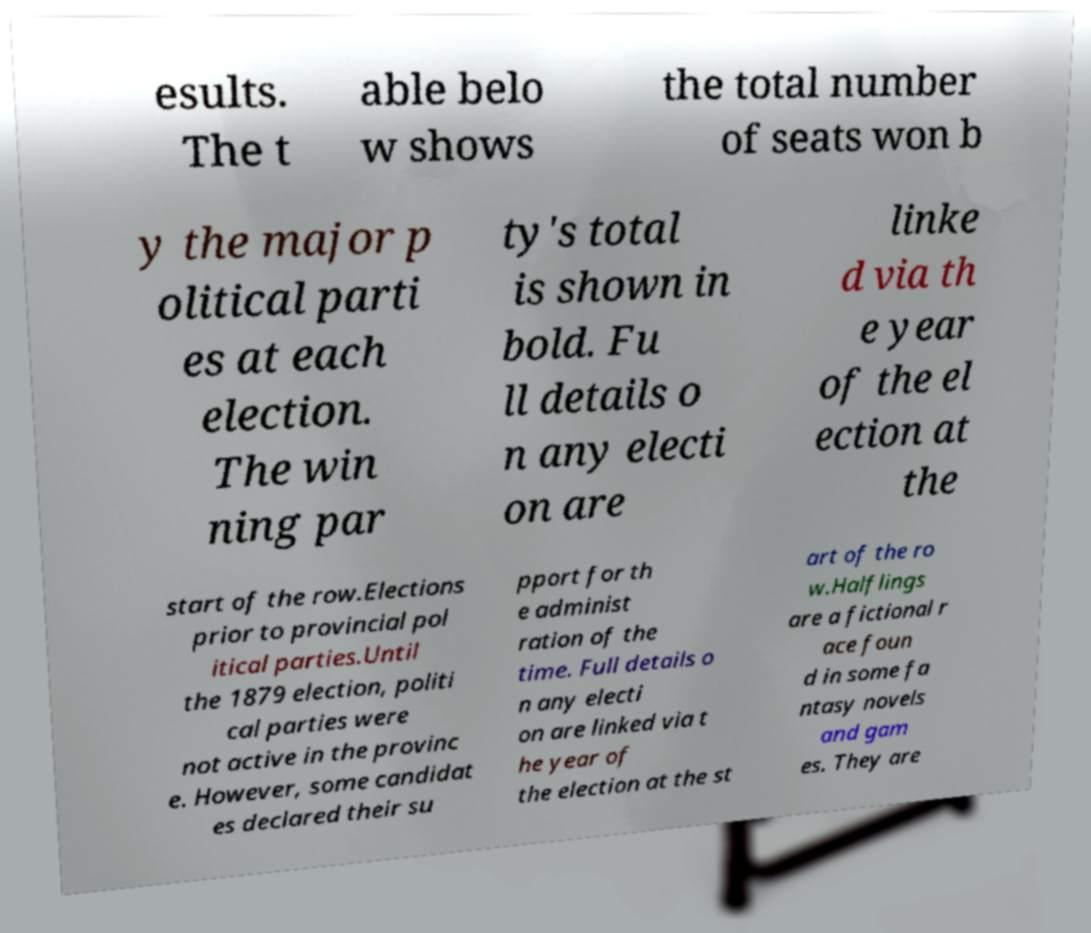Could you extract and type out the text from this image? esults. The t able belo w shows the total number of seats won b y the major p olitical parti es at each election. The win ning par ty's total is shown in bold. Fu ll details o n any electi on are linke d via th e year of the el ection at the start of the row.Elections prior to provincial pol itical parties.Until the 1879 election, politi cal parties were not active in the provinc e. However, some candidat es declared their su pport for th e administ ration of the time. Full details o n any electi on are linked via t he year of the election at the st art of the ro w.Halflings are a fictional r ace foun d in some fa ntasy novels and gam es. They are 